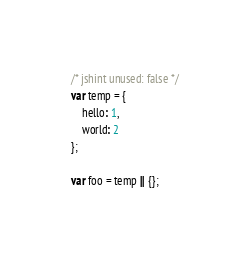Convert code to text. <code><loc_0><loc_0><loc_500><loc_500><_JavaScript_>/* jshint unused: false */
var temp = {
    hello: 1,
    world: 2
};

var foo = temp || {};
</code> 